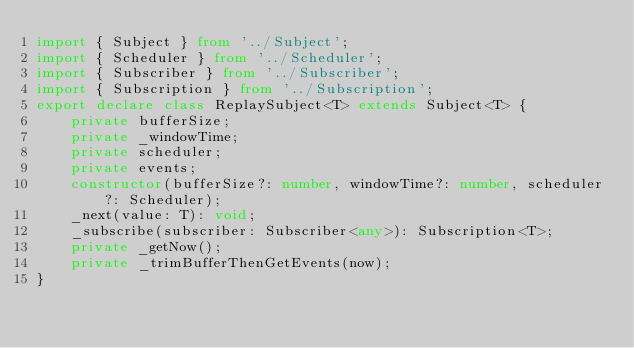Convert code to text. <code><loc_0><loc_0><loc_500><loc_500><_TypeScript_>import { Subject } from '../Subject';
import { Scheduler } from '../Scheduler';
import { Subscriber } from '../Subscriber';
import { Subscription } from '../Subscription';
export declare class ReplaySubject<T> extends Subject<T> {
    private bufferSize;
    private _windowTime;
    private scheduler;
    private events;
    constructor(bufferSize?: number, windowTime?: number, scheduler?: Scheduler);
    _next(value: T): void;
    _subscribe(subscriber: Subscriber<any>): Subscription<T>;
    private _getNow();
    private _trimBufferThenGetEvents(now);
}
</code> 